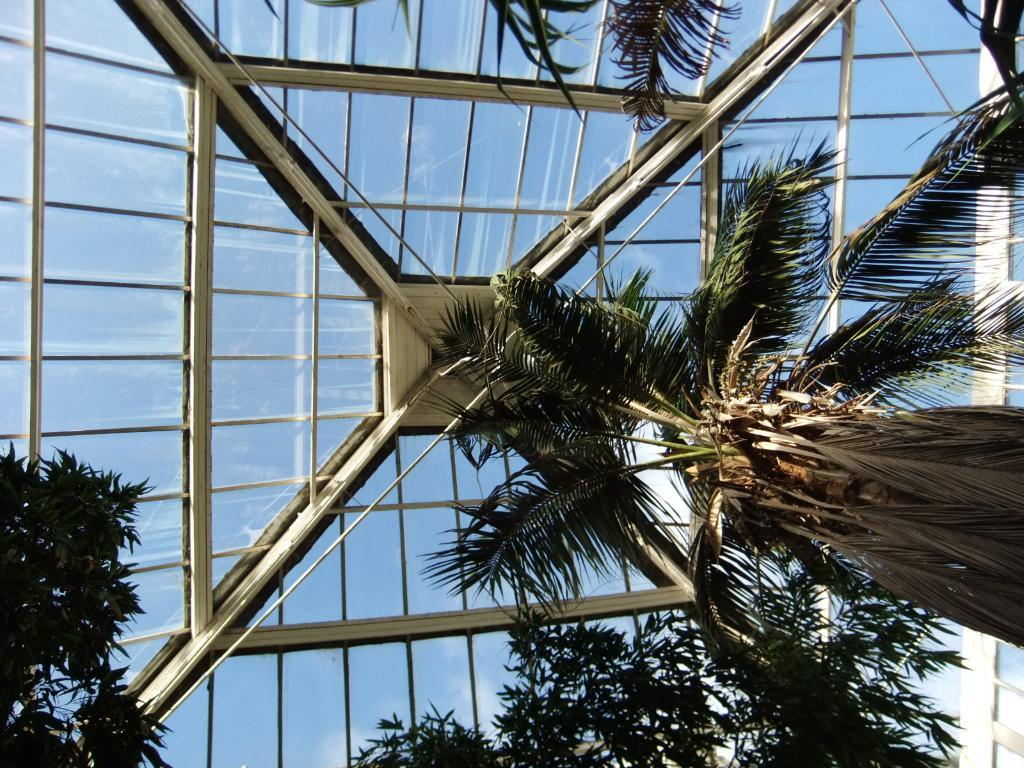What type of vegetation can be seen in the image? There are trees in the image. What is located on the roof top in the image? The roof top has metal grills and glass. What is the condition of the sky in the image? The sky is clear and visible in the image. What type of crib is visible in the image? There is no crib present in the image. What shape is the roof top in the image? The provided facts do not mention the shape of the roof top, so we cannot determine its shape from the image. 